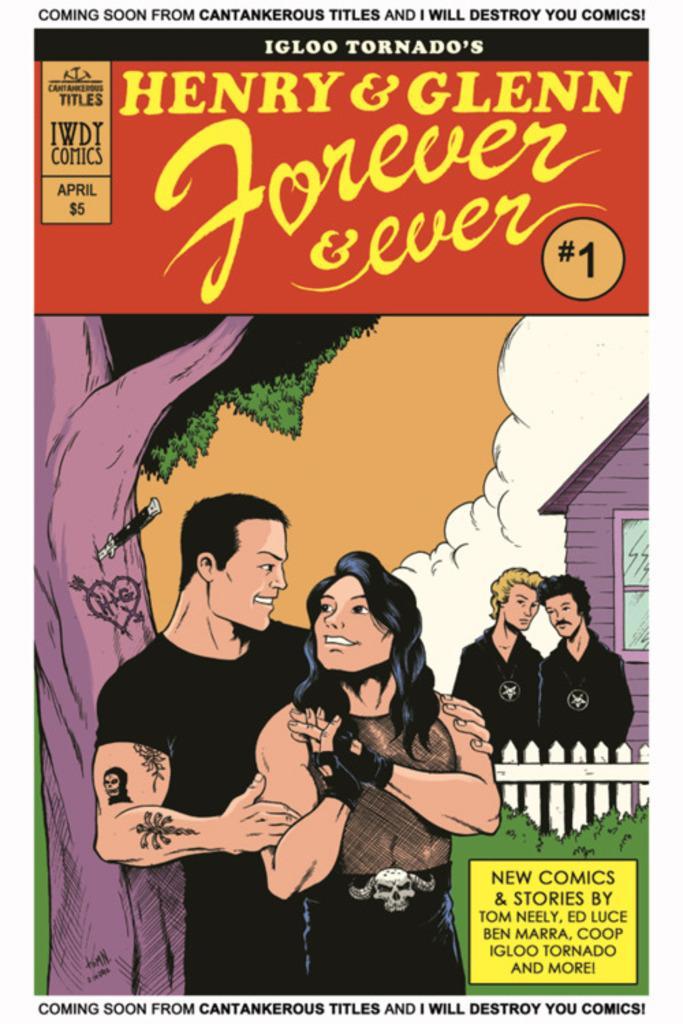Describe this image in one or two sentences. This is the poster of a cartoon were we can see one woman and man is standing in a black dress. Behind tree is there. Right side of the image two persons are standing and one house is present. Top of the image some text is written. 